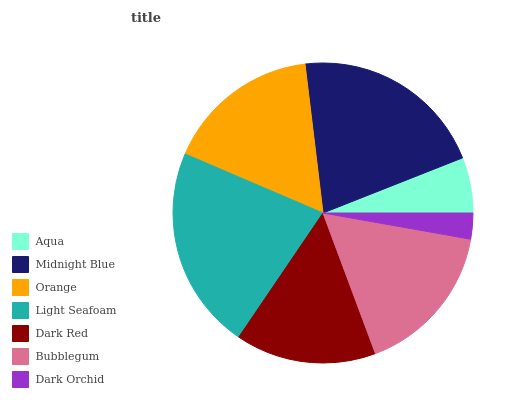Is Dark Orchid the minimum?
Answer yes or no. Yes. Is Light Seafoam the maximum?
Answer yes or no. Yes. Is Midnight Blue the minimum?
Answer yes or no. No. Is Midnight Blue the maximum?
Answer yes or no. No. Is Midnight Blue greater than Aqua?
Answer yes or no. Yes. Is Aqua less than Midnight Blue?
Answer yes or no. Yes. Is Aqua greater than Midnight Blue?
Answer yes or no. No. Is Midnight Blue less than Aqua?
Answer yes or no. No. Is Bubblegum the high median?
Answer yes or no. Yes. Is Bubblegum the low median?
Answer yes or no. Yes. Is Light Seafoam the high median?
Answer yes or no. No. Is Aqua the low median?
Answer yes or no. No. 